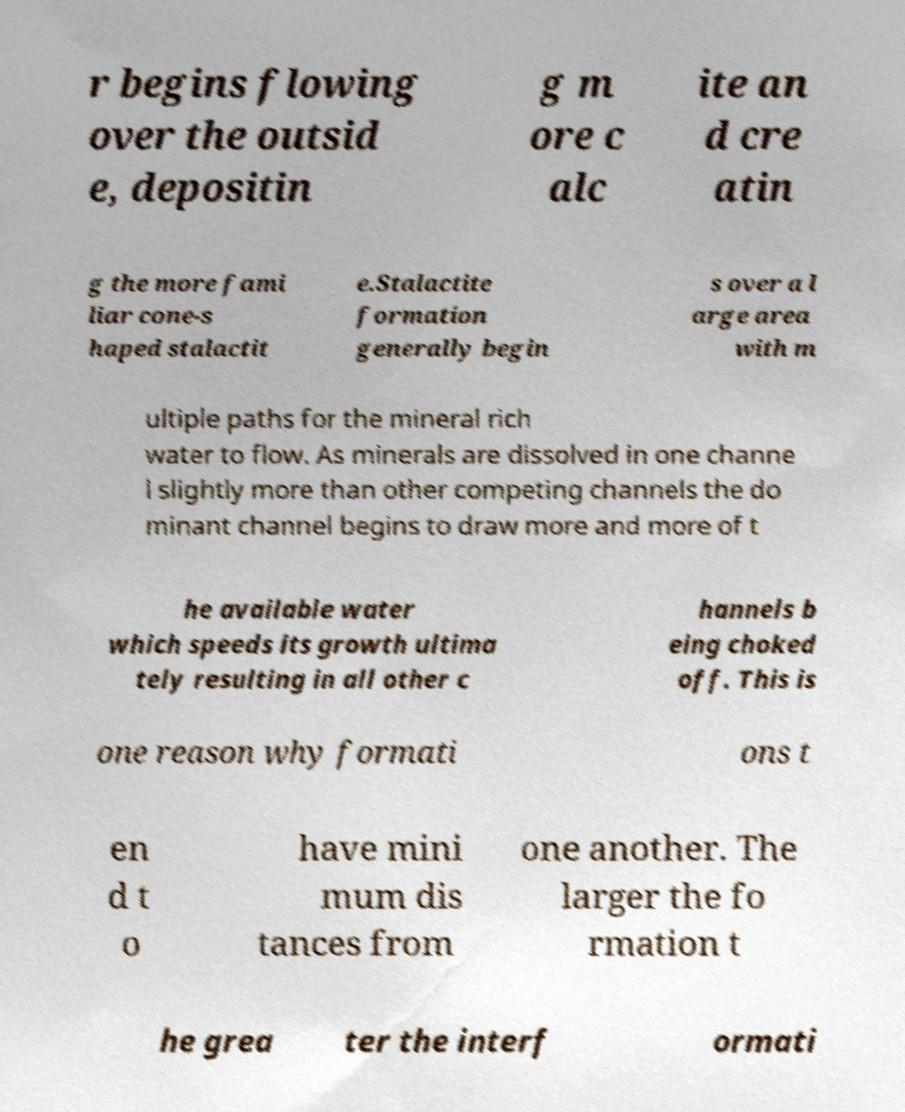Could you extract and type out the text from this image? r begins flowing over the outsid e, depositin g m ore c alc ite an d cre atin g the more fami liar cone-s haped stalactit e.Stalactite formation generally begin s over a l arge area with m ultiple paths for the mineral rich water to flow. As minerals are dissolved in one channe l slightly more than other competing channels the do minant channel begins to draw more and more of t he available water which speeds its growth ultima tely resulting in all other c hannels b eing choked off. This is one reason why formati ons t en d t o have mini mum dis tances from one another. The larger the fo rmation t he grea ter the interf ormati 